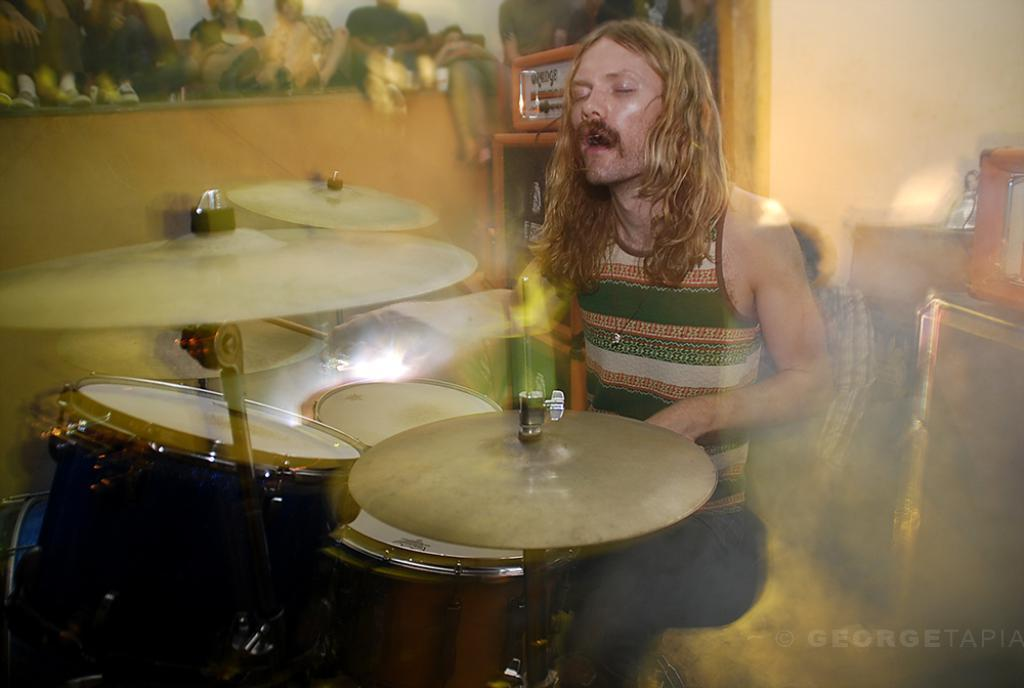What is the main subject of the image? The main subject of the image is a man. What is the man doing in the image? The man is playing musical drums in the image. How many cats are sitting on the man's foot in the image? There are no cats or feet visible in the image; it only features a man playing musical drums. 